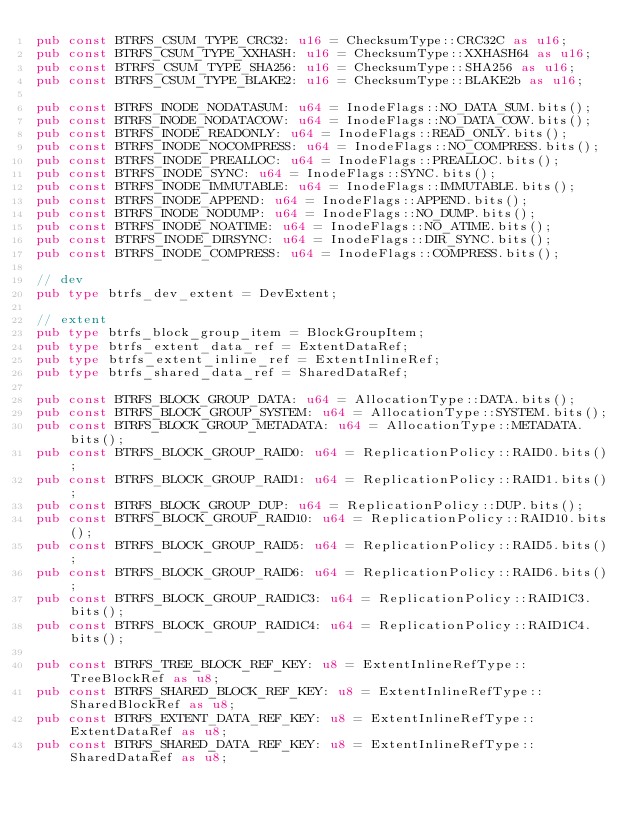<code> <loc_0><loc_0><loc_500><loc_500><_Rust_>pub const BTRFS_CSUM_TYPE_CRC32: u16 = ChecksumType::CRC32C as u16;
pub const BTRFS_CSUM_TYPE_XXHASH: u16 = ChecksumType::XXHASH64 as u16;
pub const BTRFS_CSUM_TYPE_SHA256: u16 = ChecksumType::SHA256 as u16;
pub const BTRFS_CSUM_TYPE_BLAKE2: u16 = ChecksumType::BLAKE2b as u16;

pub const BTRFS_INODE_NODATASUM: u64 = InodeFlags::NO_DATA_SUM.bits();
pub const BTRFS_INODE_NODATACOW: u64 = InodeFlags::NO_DATA_COW.bits();
pub const BTRFS_INODE_READONLY: u64 = InodeFlags::READ_ONLY.bits();
pub const BTRFS_INODE_NOCOMPRESS: u64 = InodeFlags::NO_COMPRESS.bits();
pub const BTRFS_INODE_PREALLOC: u64 = InodeFlags::PREALLOC.bits();
pub const BTRFS_INODE_SYNC: u64 = InodeFlags::SYNC.bits();
pub const BTRFS_INODE_IMMUTABLE: u64 = InodeFlags::IMMUTABLE.bits();
pub const BTRFS_INODE_APPEND: u64 = InodeFlags::APPEND.bits();
pub const BTRFS_INODE_NODUMP: u64 = InodeFlags::NO_DUMP.bits();
pub const BTRFS_INODE_NOATIME: u64 = InodeFlags::NO_ATIME.bits();
pub const BTRFS_INODE_DIRSYNC: u64 = InodeFlags::DIR_SYNC.bits();
pub const BTRFS_INODE_COMPRESS: u64 = InodeFlags::COMPRESS.bits();

// dev
pub type btrfs_dev_extent = DevExtent;

// extent
pub type btrfs_block_group_item = BlockGroupItem;
pub type btrfs_extent_data_ref = ExtentDataRef;
pub type btrfs_extent_inline_ref = ExtentInlineRef;
pub type btrfs_shared_data_ref = SharedDataRef;

pub const BTRFS_BLOCK_GROUP_DATA: u64 = AllocationType::DATA.bits();
pub const BTRFS_BLOCK_GROUP_SYSTEM: u64 = AllocationType::SYSTEM.bits();
pub const BTRFS_BLOCK_GROUP_METADATA: u64 = AllocationType::METADATA.bits();
pub const BTRFS_BLOCK_GROUP_RAID0: u64 = ReplicationPolicy::RAID0.bits();
pub const BTRFS_BLOCK_GROUP_RAID1: u64 = ReplicationPolicy::RAID1.bits();
pub const BTRFS_BLOCK_GROUP_DUP: u64 = ReplicationPolicy::DUP.bits();
pub const BTRFS_BLOCK_GROUP_RAID10: u64 = ReplicationPolicy::RAID10.bits();
pub const BTRFS_BLOCK_GROUP_RAID5: u64 = ReplicationPolicy::RAID5.bits();
pub const BTRFS_BLOCK_GROUP_RAID6: u64 = ReplicationPolicy::RAID6.bits();
pub const BTRFS_BLOCK_GROUP_RAID1C3: u64 = ReplicationPolicy::RAID1C3.bits();
pub const BTRFS_BLOCK_GROUP_RAID1C4: u64 = ReplicationPolicy::RAID1C4.bits();

pub const BTRFS_TREE_BLOCK_REF_KEY: u8 = ExtentInlineRefType::TreeBlockRef as u8;
pub const BTRFS_SHARED_BLOCK_REF_KEY: u8 = ExtentInlineRefType::SharedBlockRef as u8;
pub const BTRFS_EXTENT_DATA_REF_KEY: u8 = ExtentInlineRefType::ExtentDataRef as u8;
pub const BTRFS_SHARED_DATA_REF_KEY: u8 = ExtentInlineRefType::SharedDataRef as u8;
</code> 